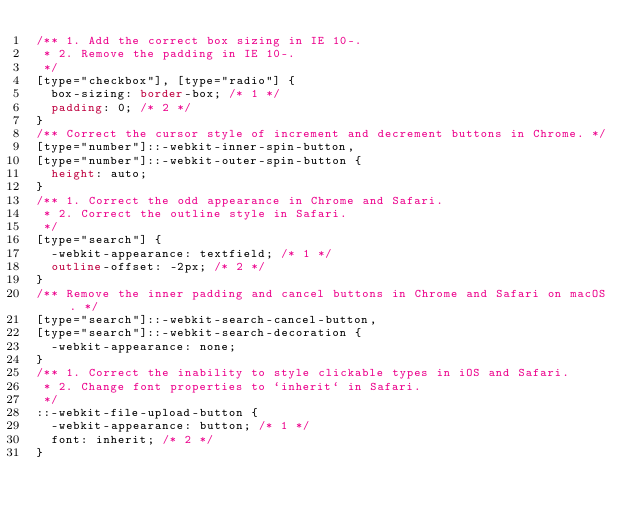Convert code to text. <code><loc_0><loc_0><loc_500><loc_500><_CSS_>/** 1. Add the correct box sizing in IE 10-.
 * 2. Remove the padding in IE 10-.
 */
[type="checkbox"], [type="radio"] {
  box-sizing: border-box; /* 1 */
  padding: 0; /* 2 */
}
/** Correct the cursor style of increment and decrement buttons in Chrome. */
[type="number"]::-webkit-inner-spin-button,
[type="number"]::-webkit-outer-spin-button {
  height: auto;
}
/** 1. Correct the odd appearance in Chrome and Safari.
 * 2. Correct the outline style in Safari.
 */
[type="search"] {
  -webkit-appearance: textfield; /* 1 */
  outline-offset: -2px; /* 2 */
}
/** Remove the inner padding and cancel buttons in Chrome and Safari on macOS. */
[type="search"]::-webkit-search-cancel-button,
[type="search"]::-webkit-search-decoration {
  -webkit-appearance: none;
}
/** 1. Correct the inability to style clickable types in iOS and Safari.
 * 2. Change font properties to `inherit` in Safari.
 */
::-webkit-file-upload-button {
  -webkit-appearance: button; /* 1 */
  font: inherit; /* 2 */
}
</code> 